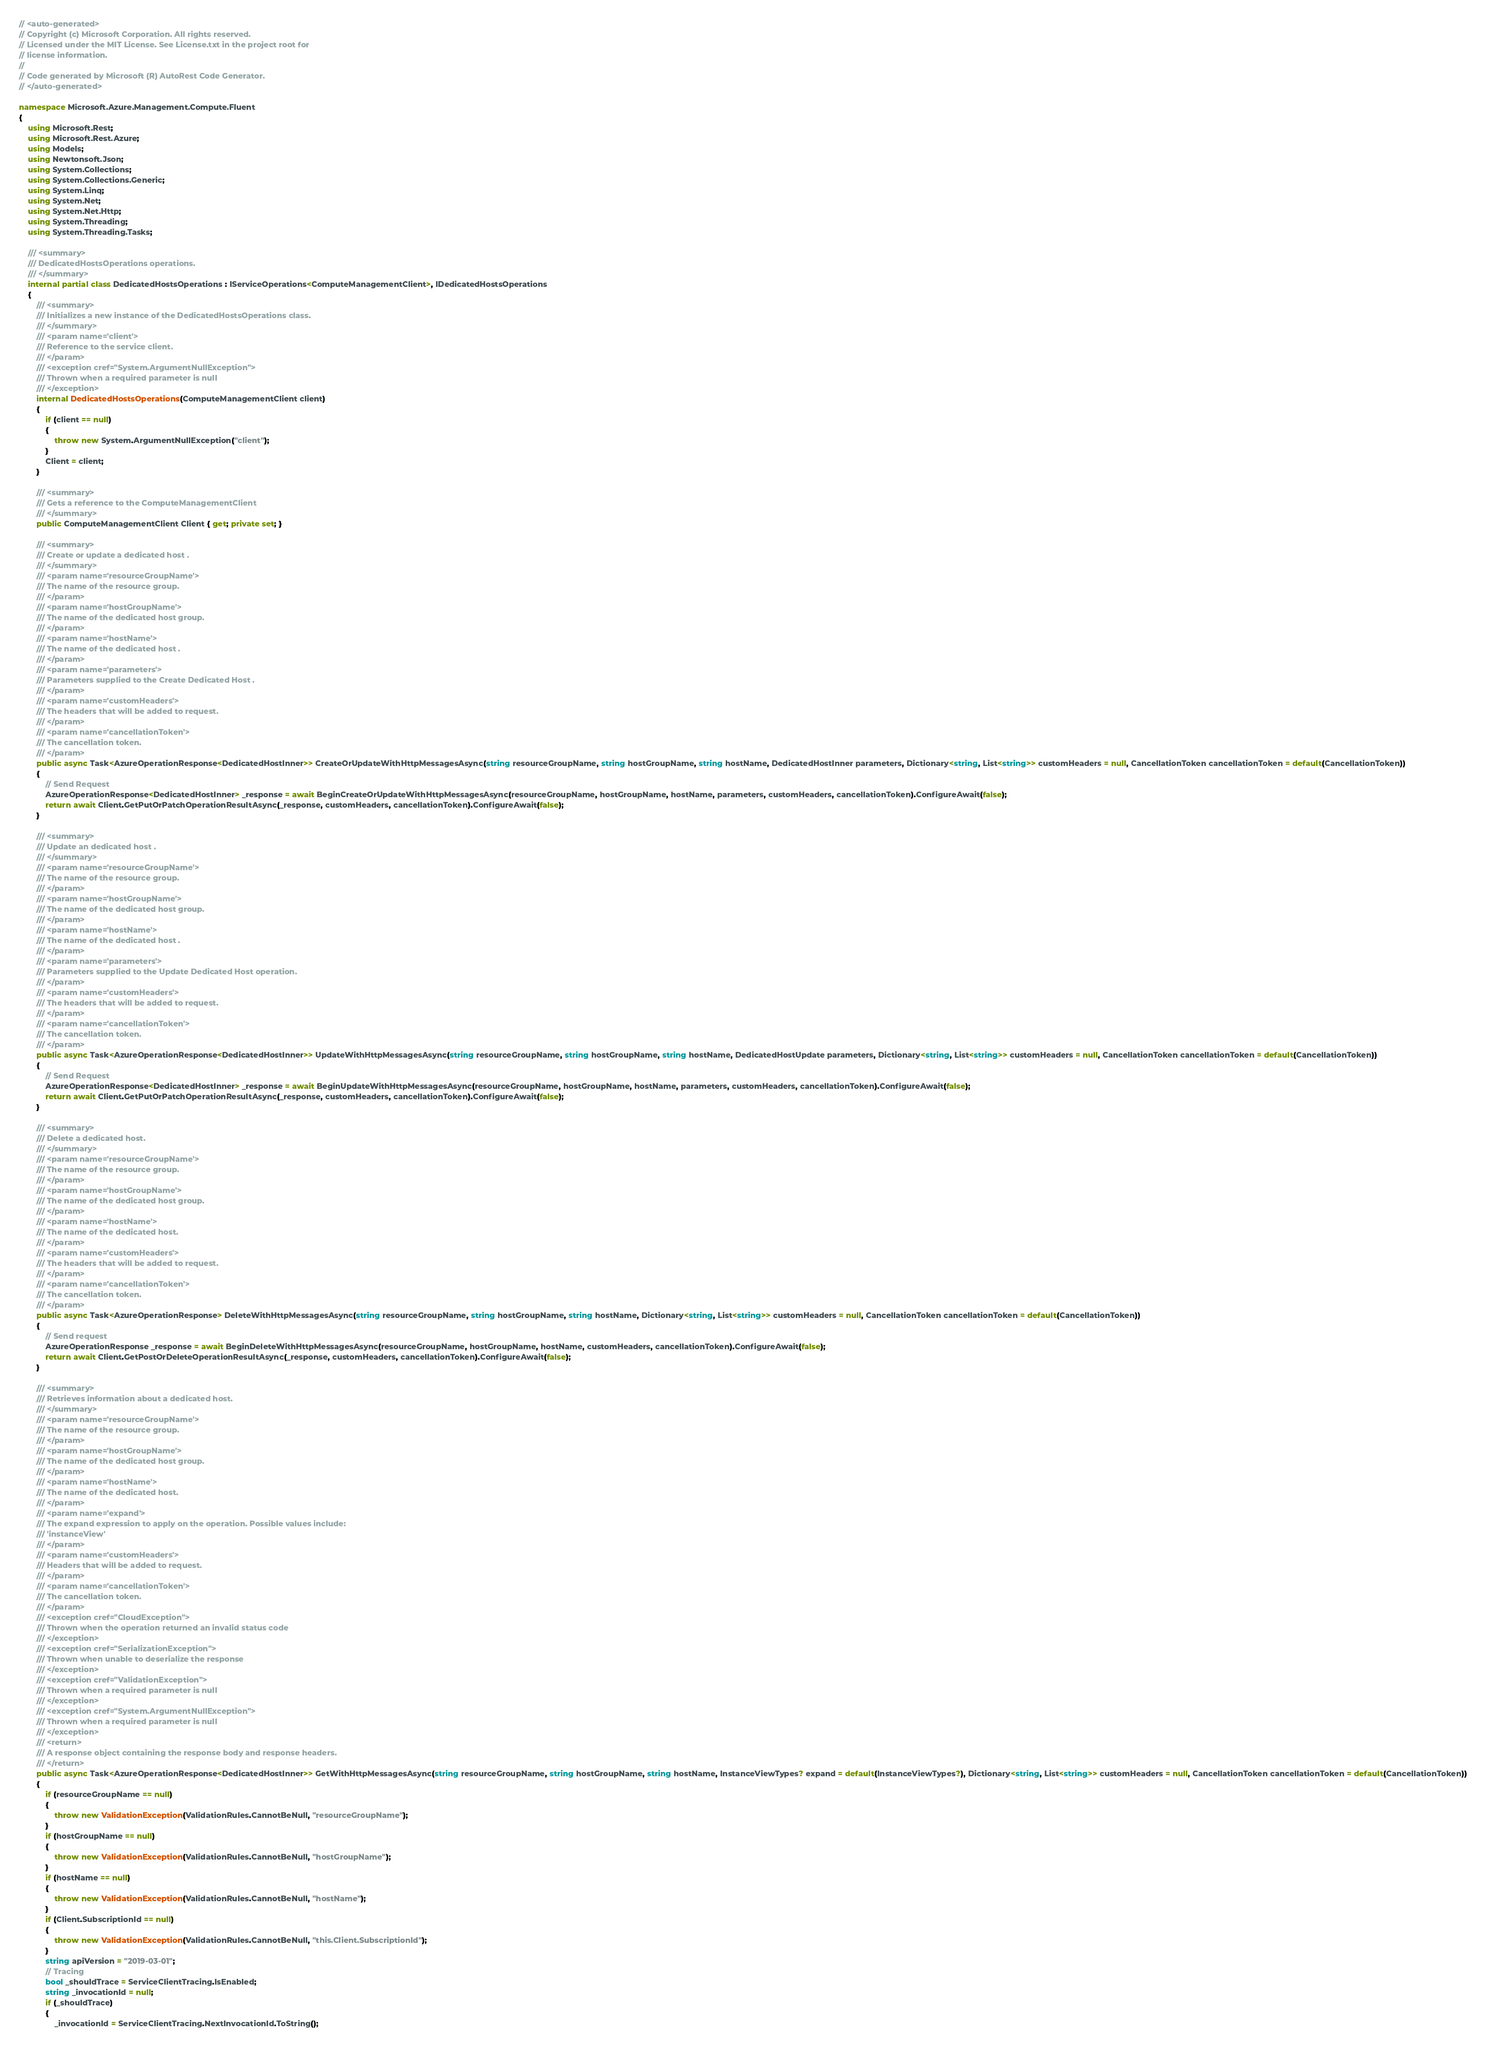Convert code to text. <code><loc_0><loc_0><loc_500><loc_500><_C#_>// <auto-generated>
// Copyright (c) Microsoft Corporation. All rights reserved.
// Licensed under the MIT License. See License.txt in the project root for
// license information.
//
// Code generated by Microsoft (R) AutoRest Code Generator.
// </auto-generated>

namespace Microsoft.Azure.Management.Compute.Fluent
{
    using Microsoft.Rest;
    using Microsoft.Rest.Azure;
    using Models;
    using Newtonsoft.Json;
    using System.Collections;
    using System.Collections.Generic;
    using System.Linq;
    using System.Net;
    using System.Net.Http;
    using System.Threading;
    using System.Threading.Tasks;

    /// <summary>
    /// DedicatedHostsOperations operations.
    /// </summary>
    internal partial class DedicatedHostsOperations : IServiceOperations<ComputeManagementClient>, IDedicatedHostsOperations
    {
        /// <summary>
        /// Initializes a new instance of the DedicatedHostsOperations class.
        /// </summary>
        /// <param name='client'>
        /// Reference to the service client.
        /// </param>
        /// <exception cref="System.ArgumentNullException">
        /// Thrown when a required parameter is null
        /// </exception>
        internal DedicatedHostsOperations(ComputeManagementClient client)
        {
            if (client == null)
            {
                throw new System.ArgumentNullException("client");
            }
            Client = client;
        }

        /// <summary>
        /// Gets a reference to the ComputeManagementClient
        /// </summary>
        public ComputeManagementClient Client { get; private set; }

        /// <summary>
        /// Create or update a dedicated host .
        /// </summary>
        /// <param name='resourceGroupName'>
        /// The name of the resource group.
        /// </param>
        /// <param name='hostGroupName'>
        /// The name of the dedicated host group.
        /// </param>
        /// <param name='hostName'>
        /// The name of the dedicated host .
        /// </param>
        /// <param name='parameters'>
        /// Parameters supplied to the Create Dedicated Host .
        /// </param>
        /// <param name='customHeaders'>
        /// The headers that will be added to request.
        /// </param>
        /// <param name='cancellationToken'>
        /// The cancellation token.
        /// </param>
        public async Task<AzureOperationResponse<DedicatedHostInner>> CreateOrUpdateWithHttpMessagesAsync(string resourceGroupName, string hostGroupName, string hostName, DedicatedHostInner parameters, Dictionary<string, List<string>> customHeaders = null, CancellationToken cancellationToken = default(CancellationToken))
        {
            // Send Request
            AzureOperationResponse<DedicatedHostInner> _response = await BeginCreateOrUpdateWithHttpMessagesAsync(resourceGroupName, hostGroupName, hostName, parameters, customHeaders, cancellationToken).ConfigureAwait(false);
            return await Client.GetPutOrPatchOperationResultAsync(_response, customHeaders, cancellationToken).ConfigureAwait(false);
        }

        /// <summary>
        /// Update an dedicated host .
        /// </summary>
        /// <param name='resourceGroupName'>
        /// The name of the resource group.
        /// </param>
        /// <param name='hostGroupName'>
        /// The name of the dedicated host group.
        /// </param>
        /// <param name='hostName'>
        /// The name of the dedicated host .
        /// </param>
        /// <param name='parameters'>
        /// Parameters supplied to the Update Dedicated Host operation.
        /// </param>
        /// <param name='customHeaders'>
        /// The headers that will be added to request.
        /// </param>
        /// <param name='cancellationToken'>
        /// The cancellation token.
        /// </param>
        public async Task<AzureOperationResponse<DedicatedHostInner>> UpdateWithHttpMessagesAsync(string resourceGroupName, string hostGroupName, string hostName, DedicatedHostUpdate parameters, Dictionary<string, List<string>> customHeaders = null, CancellationToken cancellationToken = default(CancellationToken))
        {
            // Send Request
            AzureOperationResponse<DedicatedHostInner> _response = await BeginUpdateWithHttpMessagesAsync(resourceGroupName, hostGroupName, hostName, parameters, customHeaders, cancellationToken).ConfigureAwait(false);
            return await Client.GetPutOrPatchOperationResultAsync(_response, customHeaders, cancellationToken).ConfigureAwait(false);
        }

        /// <summary>
        /// Delete a dedicated host.
        /// </summary>
        /// <param name='resourceGroupName'>
        /// The name of the resource group.
        /// </param>
        /// <param name='hostGroupName'>
        /// The name of the dedicated host group.
        /// </param>
        /// <param name='hostName'>
        /// The name of the dedicated host.
        /// </param>
        /// <param name='customHeaders'>
        /// The headers that will be added to request.
        /// </param>
        /// <param name='cancellationToken'>
        /// The cancellation token.
        /// </param>
        public async Task<AzureOperationResponse> DeleteWithHttpMessagesAsync(string resourceGroupName, string hostGroupName, string hostName, Dictionary<string, List<string>> customHeaders = null, CancellationToken cancellationToken = default(CancellationToken))
        {
            // Send request
            AzureOperationResponse _response = await BeginDeleteWithHttpMessagesAsync(resourceGroupName, hostGroupName, hostName, customHeaders, cancellationToken).ConfigureAwait(false);
            return await Client.GetPostOrDeleteOperationResultAsync(_response, customHeaders, cancellationToken).ConfigureAwait(false);
        }

        /// <summary>
        /// Retrieves information about a dedicated host.
        /// </summary>
        /// <param name='resourceGroupName'>
        /// The name of the resource group.
        /// </param>
        /// <param name='hostGroupName'>
        /// The name of the dedicated host group.
        /// </param>
        /// <param name='hostName'>
        /// The name of the dedicated host.
        /// </param>
        /// <param name='expand'>
        /// The expand expression to apply on the operation. Possible values include:
        /// 'instanceView'
        /// </param>
        /// <param name='customHeaders'>
        /// Headers that will be added to request.
        /// </param>
        /// <param name='cancellationToken'>
        /// The cancellation token.
        /// </param>
        /// <exception cref="CloudException">
        /// Thrown when the operation returned an invalid status code
        /// </exception>
        /// <exception cref="SerializationException">
        /// Thrown when unable to deserialize the response
        /// </exception>
        /// <exception cref="ValidationException">
        /// Thrown when a required parameter is null
        /// </exception>
        /// <exception cref="System.ArgumentNullException">
        /// Thrown when a required parameter is null
        /// </exception>
        /// <return>
        /// A response object containing the response body and response headers.
        /// </return>
        public async Task<AzureOperationResponse<DedicatedHostInner>> GetWithHttpMessagesAsync(string resourceGroupName, string hostGroupName, string hostName, InstanceViewTypes? expand = default(InstanceViewTypes?), Dictionary<string, List<string>> customHeaders = null, CancellationToken cancellationToken = default(CancellationToken))
        {
            if (resourceGroupName == null)
            {
                throw new ValidationException(ValidationRules.CannotBeNull, "resourceGroupName");
            }
            if (hostGroupName == null)
            {
                throw new ValidationException(ValidationRules.CannotBeNull, "hostGroupName");
            }
            if (hostName == null)
            {
                throw new ValidationException(ValidationRules.CannotBeNull, "hostName");
            }
            if (Client.SubscriptionId == null)
            {
                throw new ValidationException(ValidationRules.CannotBeNull, "this.Client.SubscriptionId");
            }
            string apiVersion = "2019-03-01";
            // Tracing
            bool _shouldTrace = ServiceClientTracing.IsEnabled;
            string _invocationId = null;
            if (_shouldTrace)
            {
                _invocationId = ServiceClientTracing.NextInvocationId.ToString();</code> 